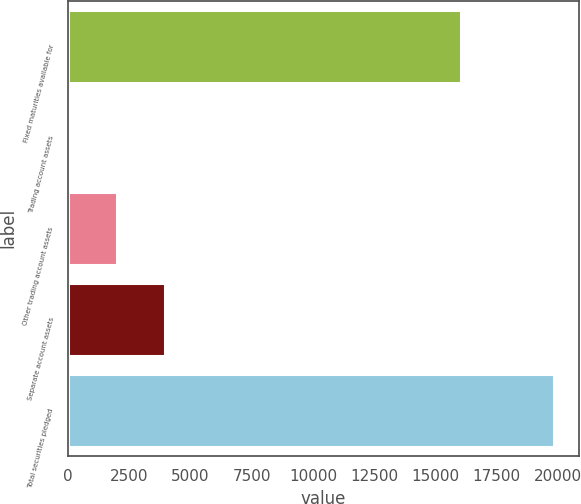<chart> <loc_0><loc_0><loc_500><loc_500><bar_chart><fcel>Fixed maturities available for<fcel>Trading account assets<fcel>Other trading account assets<fcel>Separate account assets<fcel>Total securities pledged<nl><fcel>16037<fcel>2<fcel>1986.2<fcel>3970.4<fcel>19844<nl></chart> 